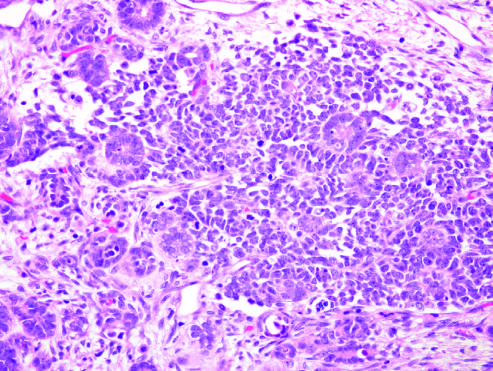what is the wilms tumor with tightly packed blue cells consistent with?
Answer the question using a single word or phrase. The blastemal component and interspersed primitive tubules 